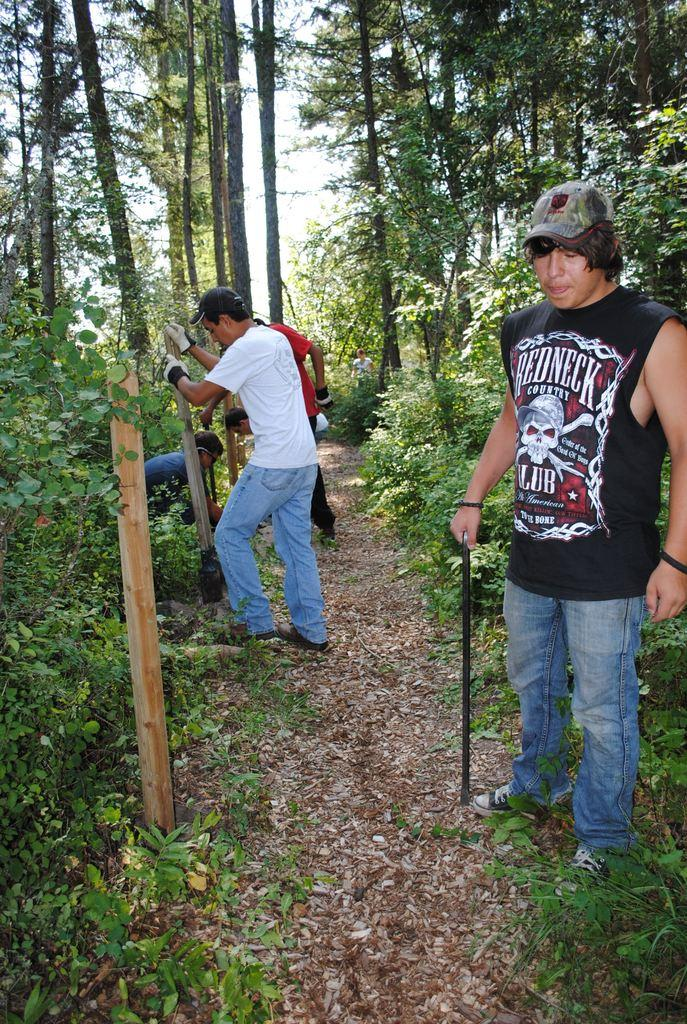How many people are in the image? There are people in the image, but the exact number is not specified. What are the people doing in the image? The people are standing and erecting wooden poles into the ground. What type of vegetation can be seen in the image? Trees and plants are present in the image. What color is the office in the image? There is no office present in the image. 